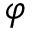Convert formula to latex. <formula><loc_0><loc_0><loc_500><loc_500>\varphi</formula> 